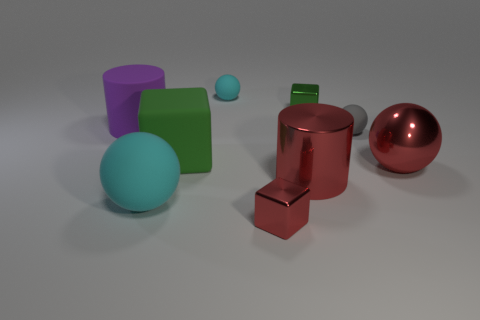Is the purple rubber thing the same size as the gray matte object?
Offer a terse response. No. Are there any other things that have the same shape as the gray object?
Ensure brevity in your answer.  Yes. Are the big cyan thing and the small thing that is in front of the large cyan object made of the same material?
Your answer should be compact. No. There is a metal block behind the big green object; is its color the same as the large matte block?
Offer a terse response. Yes. What number of metallic objects are in front of the small green metal thing and on the left side of the big metallic sphere?
Provide a short and direct response. 2. How many other objects are there of the same material as the red sphere?
Your answer should be very brief. 3. Does the tiny thing in front of the tiny gray sphere have the same material as the tiny green block?
Your response must be concise. Yes. What size is the matte cylinder that is behind the cylinder right of the small block that is left of the shiny cylinder?
Keep it short and to the point. Large. What number of other objects are the same color as the matte cylinder?
Keep it short and to the point. 0. What is the shape of the cyan object that is the same size as the rubber block?
Offer a very short reply. Sphere. 